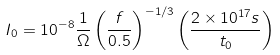Convert formula to latex. <formula><loc_0><loc_0><loc_500><loc_500>I _ { 0 } = 1 0 ^ { - 8 } \frac { 1 } { \Omega } \left ( \frac { f } { 0 . 5 } \right ) ^ { - 1 / 3 } \left ( \frac { 2 \times 1 0 ^ { 1 7 } s } { t _ { 0 } } \right )</formula> 